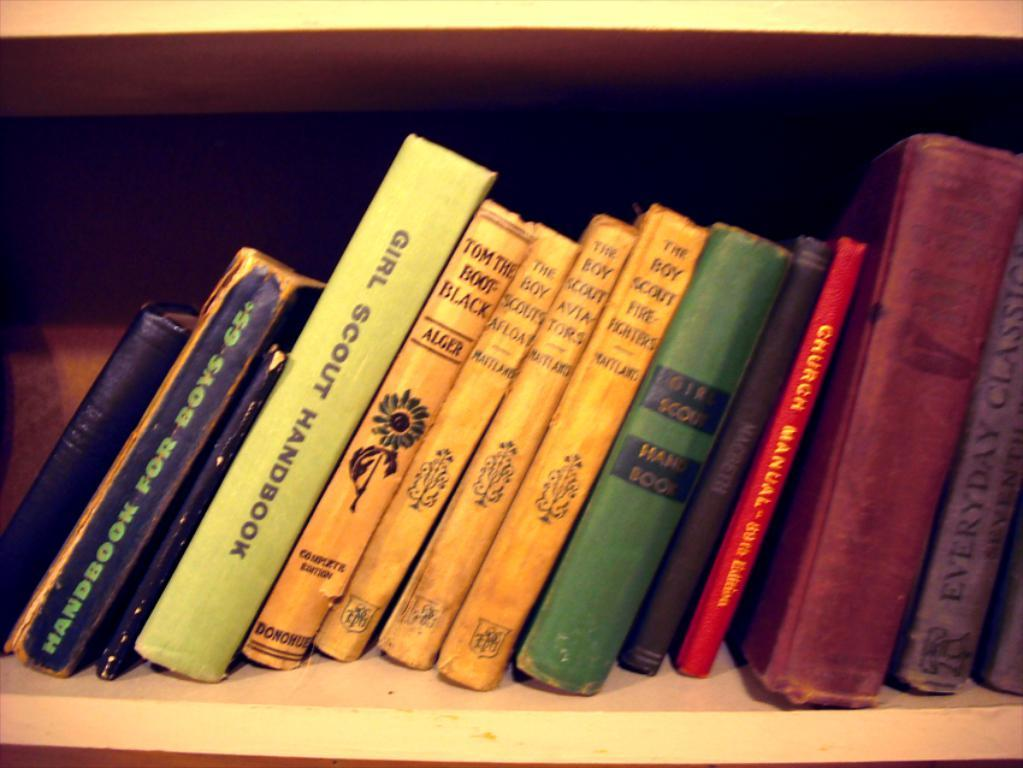<image>
Share a concise interpretation of the image provided. Books on a bookshelf containing a Girl Scout Handbook 